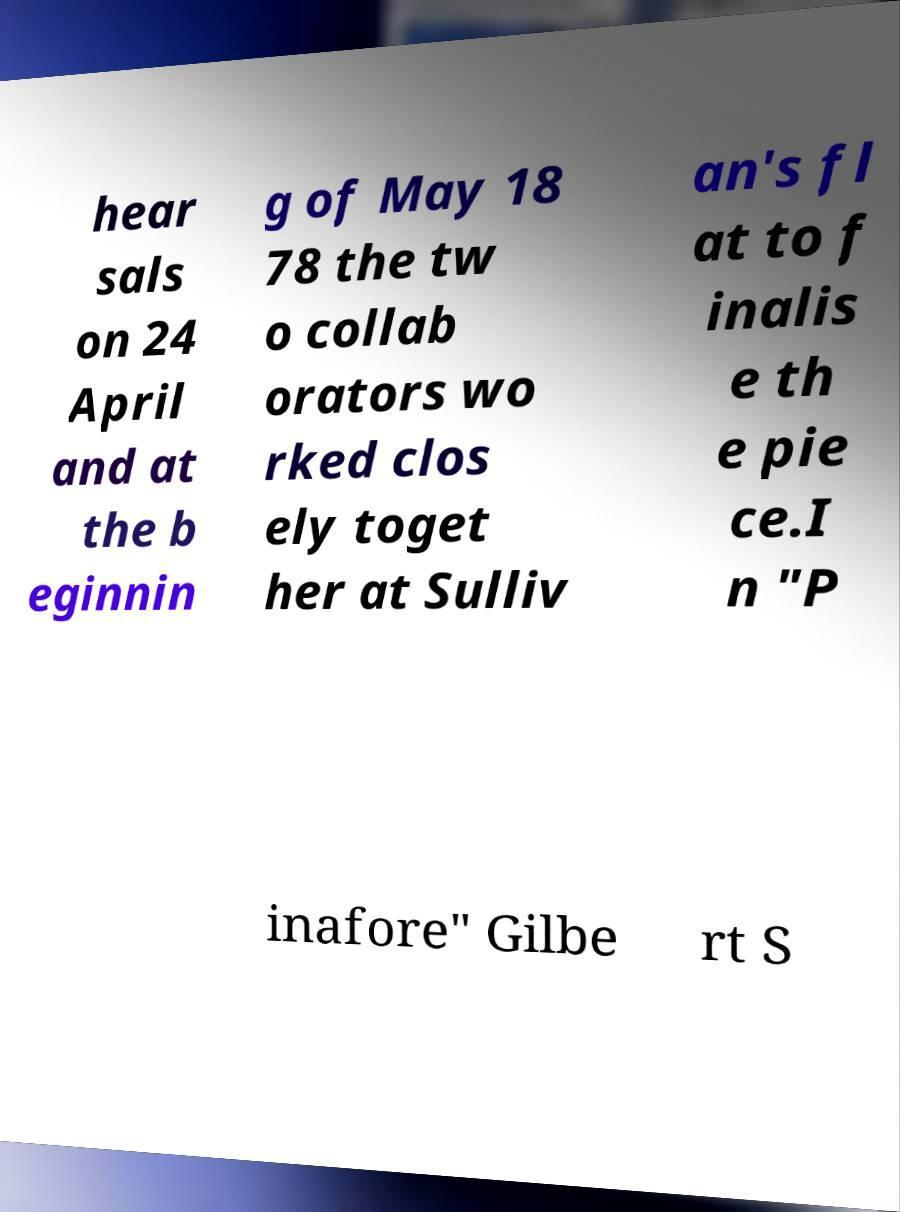Can you read and provide the text displayed in the image?This photo seems to have some interesting text. Can you extract and type it out for me? hear sals on 24 April and at the b eginnin g of May 18 78 the tw o collab orators wo rked clos ely toget her at Sulliv an's fl at to f inalis e th e pie ce.I n "P inafore" Gilbe rt S 